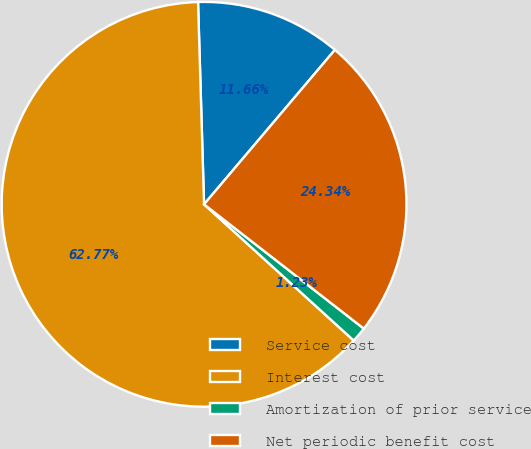Convert chart. <chart><loc_0><loc_0><loc_500><loc_500><pie_chart><fcel>Service cost<fcel>Interest cost<fcel>Amortization of prior service<fcel>Net periodic benefit cost<nl><fcel>11.66%<fcel>62.78%<fcel>1.23%<fcel>24.34%<nl></chart> 